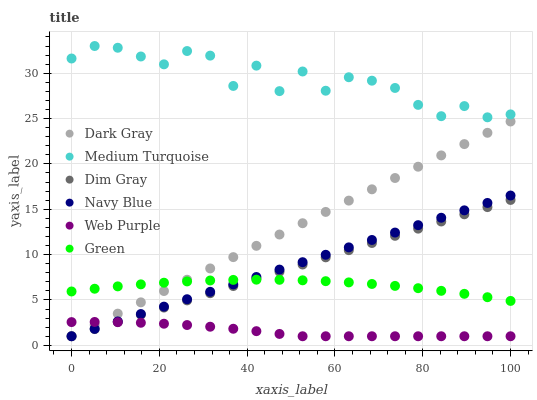Does Web Purple have the minimum area under the curve?
Answer yes or no. Yes. Does Medium Turquoise have the maximum area under the curve?
Answer yes or no. Yes. Does Navy Blue have the minimum area under the curve?
Answer yes or no. No. Does Navy Blue have the maximum area under the curve?
Answer yes or no. No. Is Navy Blue the smoothest?
Answer yes or no. Yes. Is Medium Turquoise the roughest?
Answer yes or no. Yes. Is Dark Gray the smoothest?
Answer yes or no. No. Is Dark Gray the roughest?
Answer yes or no. No. Does Dim Gray have the lowest value?
Answer yes or no. Yes. Does Green have the lowest value?
Answer yes or no. No. Does Medium Turquoise have the highest value?
Answer yes or no. Yes. Does Navy Blue have the highest value?
Answer yes or no. No. Is Web Purple less than Medium Turquoise?
Answer yes or no. Yes. Is Medium Turquoise greater than Navy Blue?
Answer yes or no. Yes. Does Green intersect Navy Blue?
Answer yes or no. Yes. Is Green less than Navy Blue?
Answer yes or no. No. Is Green greater than Navy Blue?
Answer yes or no. No. Does Web Purple intersect Medium Turquoise?
Answer yes or no. No. 